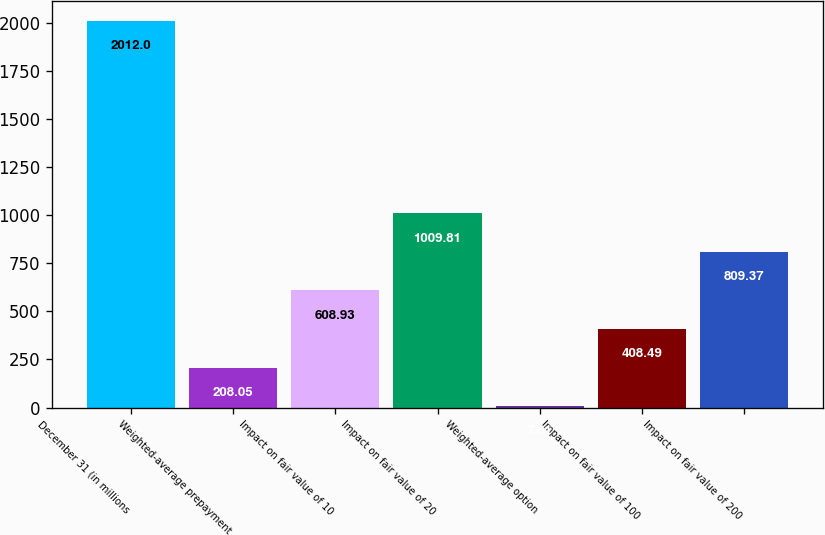<chart> <loc_0><loc_0><loc_500><loc_500><bar_chart><fcel>December 31 (in millions<fcel>Weighted-average prepayment<fcel>Impact on fair value of 10<fcel>Impact on fair value of 20<fcel>Weighted-average option<fcel>Impact on fair value of 100<fcel>Impact on fair value of 200<nl><fcel>2012<fcel>208.05<fcel>608.93<fcel>1009.81<fcel>7.61<fcel>408.49<fcel>809.37<nl></chart> 